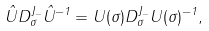<formula> <loc_0><loc_0><loc_500><loc_500>\hat { U } D ^ { J _ { - } } _ { \sigma } \hat { U } ^ { - 1 } = U ( \sigma ) D ^ { J _ { - } } _ { \sigma } U ( \sigma ) ^ { - 1 } ,</formula> 